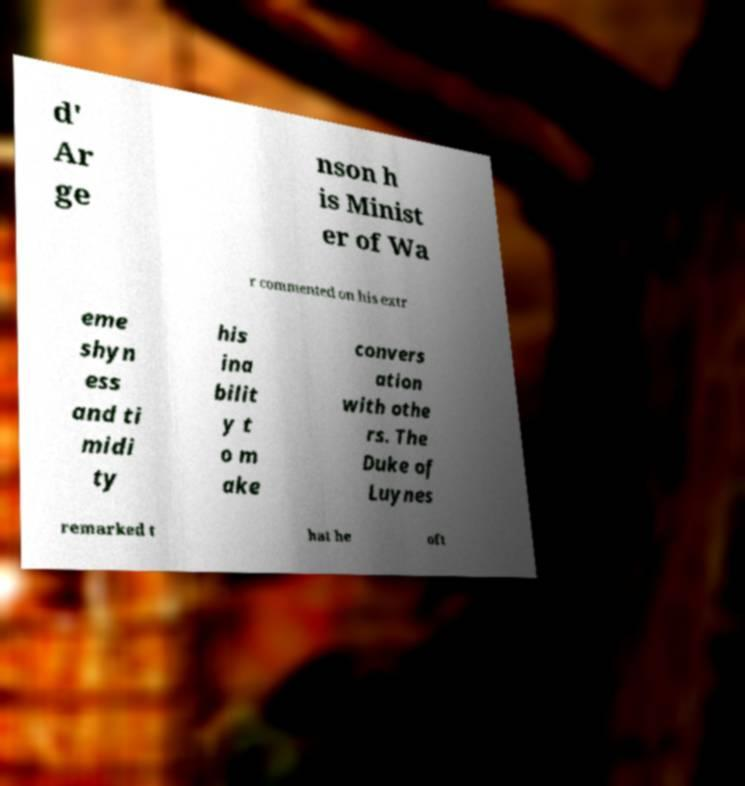Please identify and transcribe the text found in this image. d' Ar ge nson h is Minist er of Wa r commented on his extr eme shyn ess and ti midi ty his ina bilit y t o m ake convers ation with othe rs. The Duke of Luynes remarked t hat he oft 